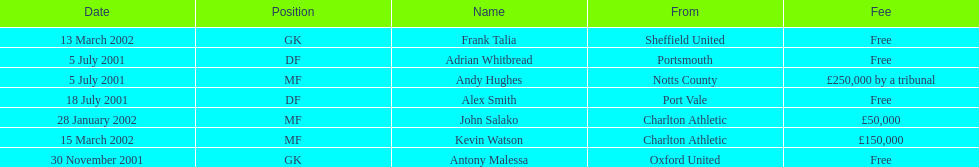Are there at least 2 nationalities on the chart? Yes. 